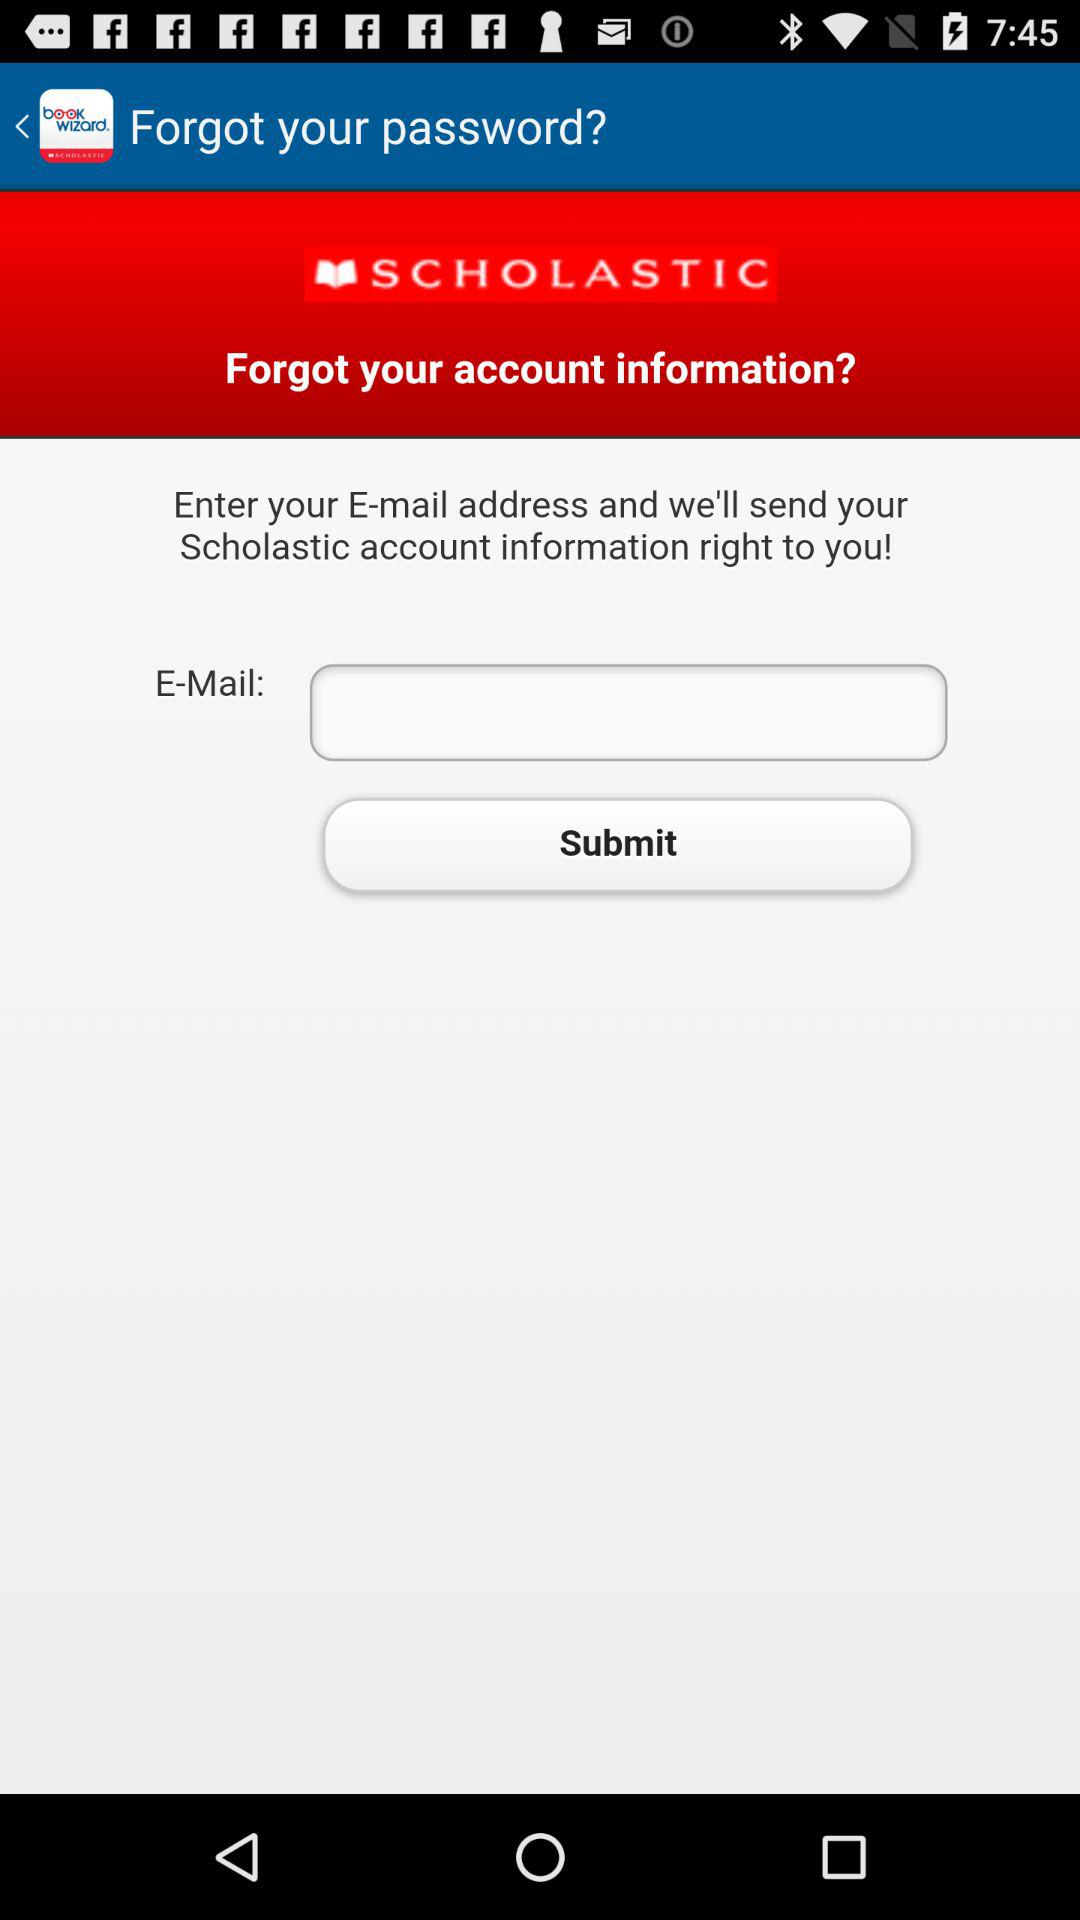What is the application name? The application name is "SCHOLASTIC". 